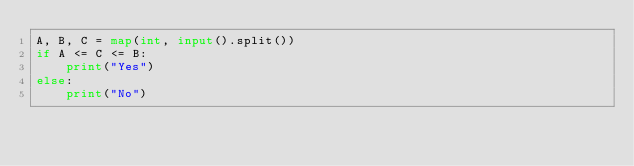<code> <loc_0><loc_0><loc_500><loc_500><_Python_>A, B, C = map(int, input().split())
if A <= C <= B:
    print("Yes")
else:
    print("No")
</code> 